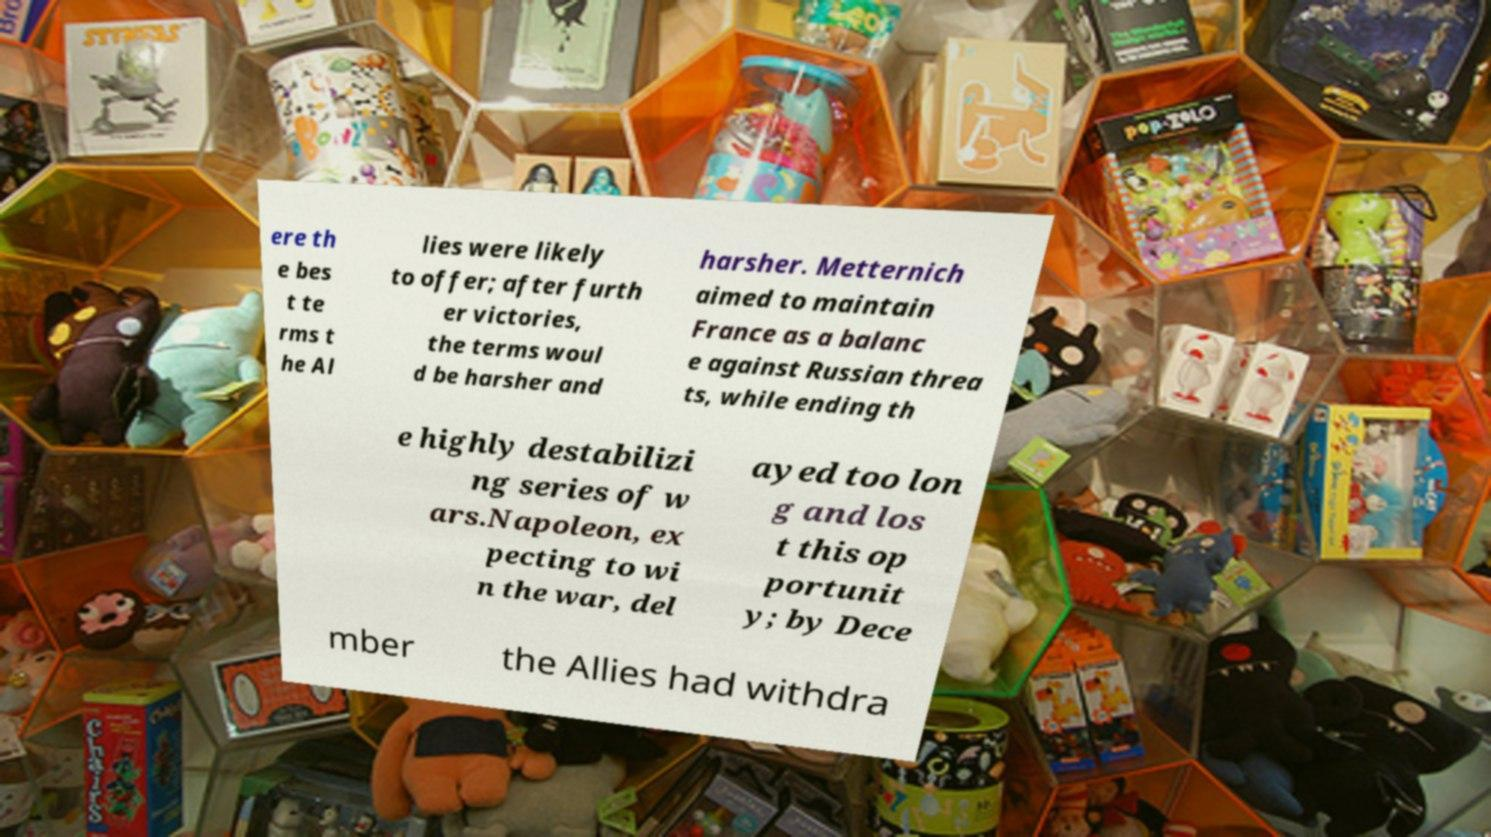What messages or text are displayed in this image? I need them in a readable, typed format. ere th e bes t te rms t he Al lies were likely to offer; after furth er victories, the terms woul d be harsher and harsher. Metternich aimed to maintain France as a balanc e against Russian threa ts, while ending th e highly destabilizi ng series of w ars.Napoleon, ex pecting to wi n the war, del ayed too lon g and los t this op portunit y; by Dece mber the Allies had withdra 